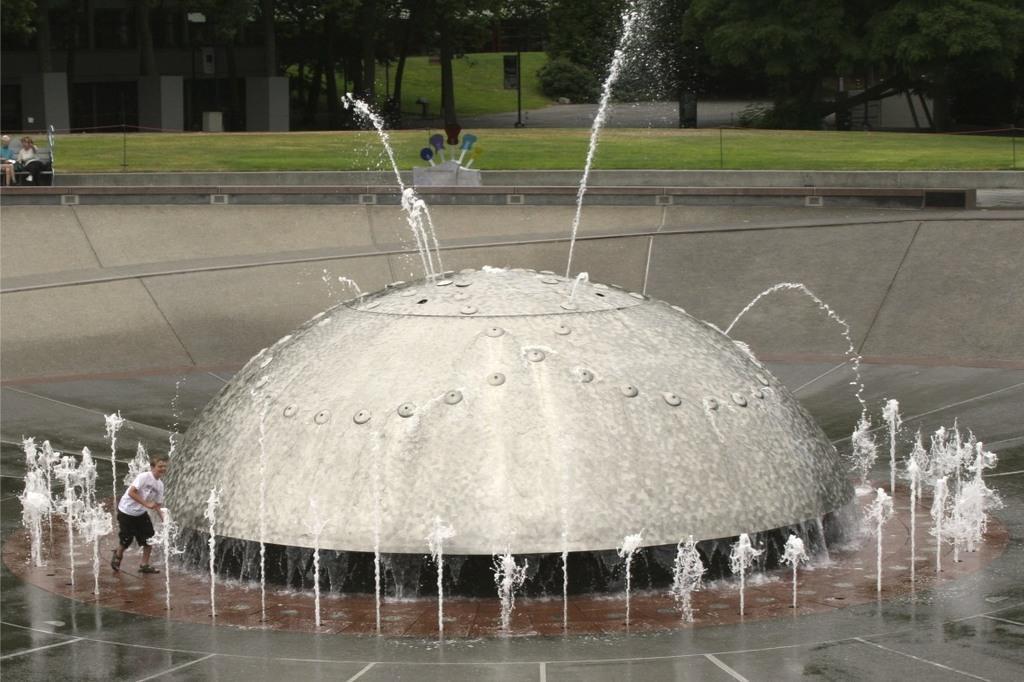Can you describe this image briefly? In the picture we can see a fountain with waterfalls and a man standing near it and he is with white T-shirt and in the background we can see two people are sitting on the bench and behind them we can see a grass surface and some trees on it. 